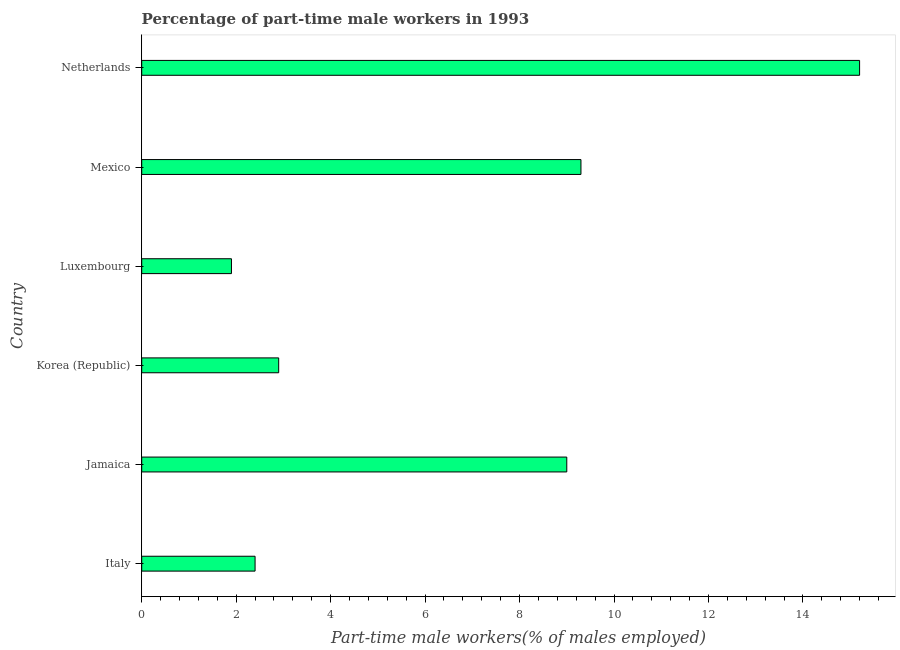What is the title of the graph?
Ensure brevity in your answer.  Percentage of part-time male workers in 1993. What is the label or title of the X-axis?
Offer a very short reply. Part-time male workers(% of males employed). What is the label or title of the Y-axis?
Your answer should be very brief. Country. What is the percentage of part-time male workers in Jamaica?
Your answer should be very brief. 9. Across all countries, what is the maximum percentage of part-time male workers?
Offer a very short reply. 15.2. Across all countries, what is the minimum percentage of part-time male workers?
Your answer should be compact. 1.9. In which country was the percentage of part-time male workers maximum?
Offer a terse response. Netherlands. In which country was the percentage of part-time male workers minimum?
Ensure brevity in your answer.  Luxembourg. What is the sum of the percentage of part-time male workers?
Your answer should be compact. 40.7. What is the difference between the percentage of part-time male workers in Korea (Republic) and Mexico?
Your answer should be compact. -6.4. What is the average percentage of part-time male workers per country?
Provide a succinct answer. 6.78. What is the median percentage of part-time male workers?
Your response must be concise. 5.95. In how many countries, is the percentage of part-time male workers greater than 7.6 %?
Your answer should be compact. 3. What is the ratio of the percentage of part-time male workers in Italy to that in Netherlands?
Ensure brevity in your answer.  0.16. Is the percentage of part-time male workers in Mexico less than that in Netherlands?
Your response must be concise. Yes. What is the difference between the highest and the second highest percentage of part-time male workers?
Provide a short and direct response. 5.9. Is the sum of the percentage of part-time male workers in Korea (Republic) and Netherlands greater than the maximum percentage of part-time male workers across all countries?
Provide a short and direct response. Yes. What is the difference between the highest and the lowest percentage of part-time male workers?
Provide a succinct answer. 13.3. How many bars are there?
Your response must be concise. 6. Are all the bars in the graph horizontal?
Provide a succinct answer. Yes. How many countries are there in the graph?
Give a very brief answer. 6. What is the difference between two consecutive major ticks on the X-axis?
Your response must be concise. 2. What is the Part-time male workers(% of males employed) of Italy?
Give a very brief answer. 2.4. What is the Part-time male workers(% of males employed) in Korea (Republic)?
Offer a very short reply. 2.9. What is the Part-time male workers(% of males employed) in Luxembourg?
Provide a succinct answer. 1.9. What is the Part-time male workers(% of males employed) of Mexico?
Offer a very short reply. 9.3. What is the Part-time male workers(% of males employed) of Netherlands?
Give a very brief answer. 15.2. What is the difference between the Part-time male workers(% of males employed) in Italy and Jamaica?
Offer a terse response. -6.6. What is the difference between the Part-time male workers(% of males employed) in Italy and Korea (Republic)?
Your answer should be compact. -0.5. What is the difference between the Part-time male workers(% of males employed) in Italy and Luxembourg?
Your answer should be very brief. 0.5. What is the difference between the Part-time male workers(% of males employed) in Italy and Mexico?
Provide a short and direct response. -6.9. What is the difference between the Part-time male workers(% of males employed) in Italy and Netherlands?
Make the answer very short. -12.8. What is the difference between the Part-time male workers(% of males employed) in Jamaica and Korea (Republic)?
Your response must be concise. 6.1. What is the difference between the Part-time male workers(% of males employed) in Jamaica and Mexico?
Provide a succinct answer. -0.3. What is the difference between the Part-time male workers(% of males employed) in Jamaica and Netherlands?
Your answer should be compact. -6.2. What is the difference between the Part-time male workers(% of males employed) in Korea (Republic) and Luxembourg?
Your response must be concise. 1. What is the difference between the Part-time male workers(% of males employed) in Luxembourg and Mexico?
Ensure brevity in your answer.  -7.4. What is the difference between the Part-time male workers(% of males employed) in Luxembourg and Netherlands?
Offer a very short reply. -13.3. What is the difference between the Part-time male workers(% of males employed) in Mexico and Netherlands?
Your answer should be very brief. -5.9. What is the ratio of the Part-time male workers(% of males employed) in Italy to that in Jamaica?
Provide a succinct answer. 0.27. What is the ratio of the Part-time male workers(% of males employed) in Italy to that in Korea (Republic)?
Provide a succinct answer. 0.83. What is the ratio of the Part-time male workers(% of males employed) in Italy to that in Luxembourg?
Make the answer very short. 1.26. What is the ratio of the Part-time male workers(% of males employed) in Italy to that in Mexico?
Ensure brevity in your answer.  0.26. What is the ratio of the Part-time male workers(% of males employed) in Italy to that in Netherlands?
Make the answer very short. 0.16. What is the ratio of the Part-time male workers(% of males employed) in Jamaica to that in Korea (Republic)?
Make the answer very short. 3.1. What is the ratio of the Part-time male workers(% of males employed) in Jamaica to that in Luxembourg?
Make the answer very short. 4.74. What is the ratio of the Part-time male workers(% of males employed) in Jamaica to that in Mexico?
Your answer should be compact. 0.97. What is the ratio of the Part-time male workers(% of males employed) in Jamaica to that in Netherlands?
Ensure brevity in your answer.  0.59. What is the ratio of the Part-time male workers(% of males employed) in Korea (Republic) to that in Luxembourg?
Provide a succinct answer. 1.53. What is the ratio of the Part-time male workers(% of males employed) in Korea (Republic) to that in Mexico?
Offer a terse response. 0.31. What is the ratio of the Part-time male workers(% of males employed) in Korea (Republic) to that in Netherlands?
Offer a terse response. 0.19. What is the ratio of the Part-time male workers(% of males employed) in Luxembourg to that in Mexico?
Offer a very short reply. 0.2. What is the ratio of the Part-time male workers(% of males employed) in Luxembourg to that in Netherlands?
Make the answer very short. 0.12. What is the ratio of the Part-time male workers(% of males employed) in Mexico to that in Netherlands?
Ensure brevity in your answer.  0.61. 